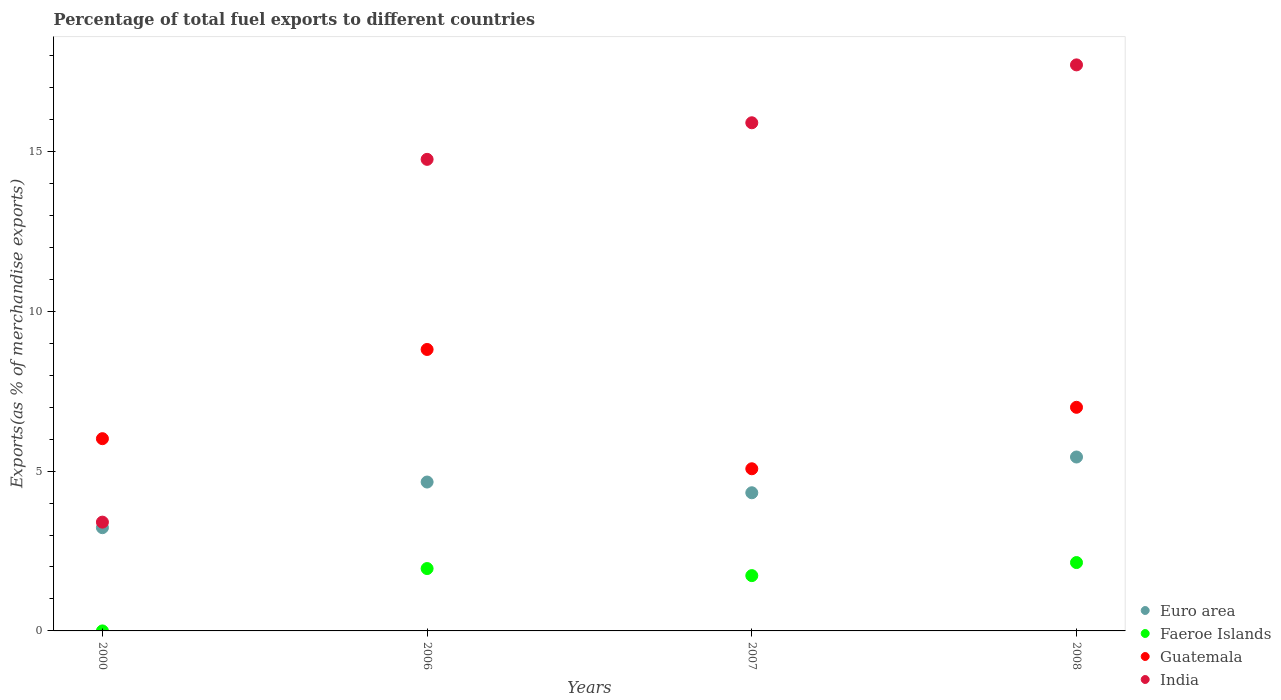What is the percentage of exports to different countries in Faeroe Islands in 2008?
Your answer should be very brief. 2.14. Across all years, what is the maximum percentage of exports to different countries in Guatemala?
Provide a short and direct response. 8.81. Across all years, what is the minimum percentage of exports to different countries in Guatemala?
Ensure brevity in your answer.  5.07. What is the total percentage of exports to different countries in Euro area in the graph?
Provide a short and direct response. 17.65. What is the difference between the percentage of exports to different countries in Guatemala in 2007 and that in 2008?
Offer a terse response. -1.92. What is the difference between the percentage of exports to different countries in Guatemala in 2006 and the percentage of exports to different countries in Euro area in 2008?
Give a very brief answer. 3.36. What is the average percentage of exports to different countries in Euro area per year?
Provide a succinct answer. 4.41. In the year 2006, what is the difference between the percentage of exports to different countries in Guatemala and percentage of exports to different countries in Euro area?
Make the answer very short. 4.15. What is the ratio of the percentage of exports to different countries in Faeroe Islands in 2006 to that in 2008?
Ensure brevity in your answer.  0.91. Is the percentage of exports to different countries in Guatemala in 2000 less than that in 2008?
Provide a succinct answer. Yes. Is the difference between the percentage of exports to different countries in Guatemala in 2000 and 2007 greater than the difference between the percentage of exports to different countries in Euro area in 2000 and 2007?
Your response must be concise. Yes. What is the difference between the highest and the second highest percentage of exports to different countries in Euro area?
Your response must be concise. 0.78. What is the difference between the highest and the lowest percentage of exports to different countries in Euro area?
Offer a terse response. 2.21. In how many years, is the percentage of exports to different countries in Faeroe Islands greater than the average percentage of exports to different countries in Faeroe Islands taken over all years?
Your response must be concise. 3. Is the sum of the percentage of exports to different countries in Faeroe Islands in 2000 and 2007 greater than the maximum percentage of exports to different countries in Euro area across all years?
Give a very brief answer. No. Is the percentage of exports to different countries in Faeroe Islands strictly less than the percentage of exports to different countries in India over the years?
Provide a short and direct response. Yes. How many dotlines are there?
Give a very brief answer. 4. Does the graph contain any zero values?
Provide a short and direct response. No. Where does the legend appear in the graph?
Offer a terse response. Bottom right. What is the title of the graph?
Give a very brief answer. Percentage of total fuel exports to different countries. What is the label or title of the X-axis?
Ensure brevity in your answer.  Years. What is the label or title of the Y-axis?
Your answer should be compact. Exports(as % of merchandise exports). What is the Exports(as % of merchandise exports) of Euro area in 2000?
Ensure brevity in your answer.  3.23. What is the Exports(as % of merchandise exports) in Faeroe Islands in 2000?
Offer a terse response. 5.55871303274651e-5. What is the Exports(as % of merchandise exports) in Guatemala in 2000?
Provide a succinct answer. 6.01. What is the Exports(as % of merchandise exports) of India in 2000?
Give a very brief answer. 3.4. What is the Exports(as % of merchandise exports) of Euro area in 2006?
Your answer should be very brief. 4.66. What is the Exports(as % of merchandise exports) in Faeroe Islands in 2006?
Your answer should be very brief. 1.95. What is the Exports(as % of merchandise exports) of Guatemala in 2006?
Ensure brevity in your answer.  8.81. What is the Exports(as % of merchandise exports) of India in 2006?
Keep it short and to the point. 14.75. What is the Exports(as % of merchandise exports) in Euro area in 2007?
Offer a very short reply. 4.32. What is the Exports(as % of merchandise exports) of Faeroe Islands in 2007?
Give a very brief answer. 1.73. What is the Exports(as % of merchandise exports) of Guatemala in 2007?
Your response must be concise. 5.07. What is the Exports(as % of merchandise exports) of India in 2007?
Provide a succinct answer. 15.9. What is the Exports(as % of merchandise exports) of Euro area in 2008?
Give a very brief answer. 5.44. What is the Exports(as % of merchandise exports) in Faeroe Islands in 2008?
Offer a very short reply. 2.14. What is the Exports(as % of merchandise exports) in Guatemala in 2008?
Keep it short and to the point. 7. What is the Exports(as % of merchandise exports) in India in 2008?
Offer a terse response. 17.71. Across all years, what is the maximum Exports(as % of merchandise exports) of Euro area?
Provide a short and direct response. 5.44. Across all years, what is the maximum Exports(as % of merchandise exports) in Faeroe Islands?
Your response must be concise. 2.14. Across all years, what is the maximum Exports(as % of merchandise exports) of Guatemala?
Your answer should be very brief. 8.81. Across all years, what is the maximum Exports(as % of merchandise exports) in India?
Make the answer very short. 17.71. Across all years, what is the minimum Exports(as % of merchandise exports) in Euro area?
Ensure brevity in your answer.  3.23. Across all years, what is the minimum Exports(as % of merchandise exports) in Faeroe Islands?
Keep it short and to the point. 5.55871303274651e-5. Across all years, what is the minimum Exports(as % of merchandise exports) in Guatemala?
Provide a succinct answer. 5.07. Across all years, what is the minimum Exports(as % of merchandise exports) in India?
Your answer should be compact. 3.4. What is the total Exports(as % of merchandise exports) in Euro area in the graph?
Keep it short and to the point. 17.65. What is the total Exports(as % of merchandise exports) of Faeroe Islands in the graph?
Your answer should be very brief. 5.82. What is the total Exports(as % of merchandise exports) in Guatemala in the graph?
Keep it short and to the point. 26.89. What is the total Exports(as % of merchandise exports) in India in the graph?
Offer a very short reply. 51.77. What is the difference between the Exports(as % of merchandise exports) in Euro area in 2000 and that in 2006?
Give a very brief answer. -1.43. What is the difference between the Exports(as % of merchandise exports) of Faeroe Islands in 2000 and that in 2006?
Ensure brevity in your answer.  -1.95. What is the difference between the Exports(as % of merchandise exports) in Guatemala in 2000 and that in 2006?
Your response must be concise. -2.79. What is the difference between the Exports(as % of merchandise exports) in India in 2000 and that in 2006?
Provide a short and direct response. -11.35. What is the difference between the Exports(as % of merchandise exports) in Euro area in 2000 and that in 2007?
Your answer should be compact. -1.09. What is the difference between the Exports(as % of merchandise exports) of Faeroe Islands in 2000 and that in 2007?
Your answer should be very brief. -1.73. What is the difference between the Exports(as % of merchandise exports) in Guatemala in 2000 and that in 2007?
Your response must be concise. 0.94. What is the difference between the Exports(as % of merchandise exports) of India in 2000 and that in 2007?
Provide a short and direct response. -12.5. What is the difference between the Exports(as % of merchandise exports) in Euro area in 2000 and that in 2008?
Provide a short and direct response. -2.21. What is the difference between the Exports(as % of merchandise exports) in Faeroe Islands in 2000 and that in 2008?
Provide a short and direct response. -2.14. What is the difference between the Exports(as % of merchandise exports) of Guatemala in 2000 and that in 2008?
Your answer should be very brief. -0.98. What is the difference between the Exports(as % of merchandise exports) of India in 2000 and that in 2008?
Make the answer very short. -14.31. What is the difference between the Exports(as % of merchandise exports) in Euro area in 2006 and that in 2007?
Keep it short and to the point. 0.34. What is the difference between the Exports(as % of merchandise exports) in Faeroe Islands in 2006 and that in 2007?
Give a very brief answer. 0.22. What is the difference between the Exports(as % of merchandise exports) in Guatemala in 2006 and that in 2007?
Offer a terse response. 3.73. What is the difference between the Exports(as % of merchandise exports) of India in 2006 and that in 2007?
Provide a succinct answer. -1.14. What is the difference between the Exports(as % of merchandise exports) of Euro area in 2006 and that in 2008?
Offer a terse response. -0.78. What is the difference between the Exports(as % of merchandise exports) in Faeroe Islands in 2006 and that in 2008?
Your answer should be compact. -0.19. What is the difference between the Exports(as % of merchandise exports) in Guatemala in 2006 and that in 2008?
Offer a terse response. 1.81. What is the difference between the Exports(as % of merchandise exports) in India in 2006 and that in 2008?
Offer a very short reply. -2.96. What is the difference between the Exports(as % of merchandise exports) in Euro area in 2007 and that in 2008?
Keep it short and to the point. -1.12. What is the difference between the Exports(as % of merchandise exports) in Faeroe Islands in 2007 and that in 2008?
Your answer should be very brief. -0.41. What is the difference between the Exports(as % of merchandise exports) in Guatemala in 2007 and that in 2008?
Provide a short and direct response. -1.92. What is the difference between the Exports(as % of merchandise exports) in India in 2007 and that in 2008?
Ensure brevity in your answer.  -1.81. What is the difference between the Exports(as % of merchandise exports) in Euro area in 2000 and the Exports(as % of merchandise exports) in Faeroe Islands in 2006?
Your answer should be very brief. 1.28. What is the difference between the Exports(as % of merchandise exports) of Euro area in 2000 and the Exports(as % of merchandise exports) of Guatemala in 2006?
Keep it short and to the point. -5.58. What is the difference between the Exports(as % of merchandise exports) in Euro area in 2000 and the Exports(as % of merchandise exports) in India in 2006?
Give a very brief answer. -11.52. What is the difference between the Exports(as % of merchandise exports) of Faeroe Islands in 2000 and the Exports(as % of merchandise exports) of Guatemala in 2006?
Your response must be concise. -8.81. What is the difference between the Exports(as % of merchandise exports) in Faeroe Islands in 2000 and the Exports(as % of merchandise exports) in India in 2006?
Your response must be concise. -14.75. What is the difference between the Exports(as % of merchandise exports) in Guatemala in 2000 and the Exports(as % of merchandise exports) in India in 2006?
Make the answer very short. -8.74. What is the difference between the Exports(as % of merchandise exports) of Euro area in 2000 and the Exports(as % of merchandise exports) of Faeroe Islands in 2007?
Provide a short and direct response. 1.5. What is the difference between the Exports(as % of merchandise exports) of Euro area in 2000 and the Exports(as % of merchandise exports) of Guatemala in 2007?
Offer a very short reply. -1.84. What is the difference between the Exports(as % of merchandise exports) in Euro area in 2000 and the Exports(as % of merchandise exports) in India in 2007?
Your answer should be compact. -12.67. What is the difference between the Exports(as % of merchandise exports) of Faeroe Islands in 2000 and the Exports(as % of merchandise exports) of Guatemala in 2007?
Offer a very short reply. -5.07. What is the difference between the Exports(as % of merchandise exports) of Faeroe Islands in 2000 and the Exports(as % of merchandise exports) of India in 2007?
Your response must be concise. -15.9. What is the difference between the Exports(as % of merchandise exports) in Guatemala in 2000 and the Exports(as % of merchandise exports) in India in 2007?
Make the answer very short. -9.88. What is the difference between the Exports(as % of merchandise exports) in Euro area in 2000 and the Exports(as % of merchandise exports) in Faeroe Islands in 2008?
Your answer should be compact. 1.09. What is the difference between the Exports(as % of merchandise exports) in Euro area in 2000 and the Exports(as % of merchandise exports) in Guatemala in 2008?
Your answer should be compact. -3.77. What is the difference between the Exports(as % of merchandise exports) in Euro area in 2000 and the Exports(as % of merchandise exports) in India in 2008?
Keep it short and to the point. -14.48. What is the difference between the Exports(as % of merchandise exports) of Faeroe Islands in 2000 and the Exports(as % of merchandise exports) of Guatemala in 2008?
Offer a very short reply. -7. What is the difference between the Exports(as % of merchandise exports) of Faeroe Islands in 2000 and the Exports(as % of merchandise exports) of India in 2008?
Your answer should be very brief. -17.71. What is the difference between the Exports(as % of merchandise exports) of Guatemala in 2000 and the Exports(as % of merchandise exports) of India in 2008?
Give a very brief answer. -11.7. What is the difference between the Exports(as % of merchandise exports) in Euro area in 2006 and the Exports(as % of merchandise exports) in Faeroe Islands in 2007?
Offer a terse response. 2.93. What is the difference between the Exports(as % of merchandise exports) in Euro area in 2006 and the Exports(as % of merchandise exports) in Guatemala in 2007?
Keep it short and to the point. -0.41. What is the difference between the Exports(as % of merchandise exports) of Euro area in 2006 and the Exports(as % of merchandise exports) of India in 2007?
Your answer should be very brief. -11.24. What is the difference between the Exports(as % of merchandise exports) in Faeroe Islands in 2006 and the Exports(as % of merchandise exports) in Guatemala in 2007?
Your answer should be very brief. -3.12. What is the difference between the Exports(as % of merchandise exports) of Faeroe Islands in 2006 and the Exports(as % of merchandise exports) of India in 2007?
Give a very brief answer. -13.95. What is the difference between the Exports(as % of merchandise exports) of Guatemala in 2006 and the Exports(as % of merchandise exports) of India in 2007?
Offer a terse response. -7.09. What is the difference between the Exports(as % of merchandise exports) in Euro area in 2006 and the Exports(as % of merchandise exports) in Faeroe Islands in 2008?
Ensure brevity in your answer.  2.52. What is the difference between the Exports(as % of merchandise exports) of Euro area in 2006 and the Exports(as % of merchandise exports) of Guatemala in 2008?
Provide a succinct answer. -2.34. What is the difference between the Exports(as % of merchandise exports) in Euro area in 2006 and the Exports(as % of merchandise exports) in India in 2008?
Provide a succinct answer. -13.05. What is the difference between the Exports(as % of merchandise exports) of Faeroe Islands in 2006 and the Exports(as % of merchandise exports) of Guatemala in 2008?
Provide a short and direct response. -5.04. What is the difference between the Exports(as % of merchandise exports) in Faeroe Islands in 2006 and the Exports(as % of merchandise exports) in India in 2008?
Offer a terse response. -15.76. What is the difference between the Exports(as % of merchandise exports) of Guatemala in 2006 and the Exports(as % of merchandise exports) of India in 2008?
Provide a succinct answer. -8.9. What is the difference between the Exports(as % of merchandise exports) of Euro area in 2007 and the Exports(as % of merchandise exports) of Faeroe Islands in 2008?
Ensure brevity in your answer.  2.18. What is the difference between the Exports(as % of merchandise exports) in Euro area in 2007 and the Exports(as % of merchandise exports) in Guatemala in 2008?
Your response must be concise. -2.67. What is the difference between the Exports(as % of merchandise exports) of Euro area in 2007 and the Exports(as % of merchandise exports) of India in 2008?
Provide a succinct answer. -13.39. What is the difference between the Exports(as % of merchandise exports) of Faeroe Islands in 2007 and the Exports(as % of merchandise exports) of Guatemala in 2008?
Give a very brief answer. -5.27. What is the difference between the Exports(as % of merchandise exports) of Faeroe Islands in 2007 and the Exports(as % of merchandise exports) of India in 2008?
Ensure brevity in your answer.  -15.98. What is the difference between the Exports(as % of merchandise exports) of Guatemala in 2007 and the Exports(as % of merchandise exports) of India in 2008?
Provide a succinct answer. -12.64. What is the average Exports(as % of merchandise exports) of Euro area per year?
Your answer should be compact. 4.41. What is the average Exports(as % of merchandise exports) in Faeroe Islands per year?
Offer a very short reply. 1.46. What is the average Exports(as % of merchandise exports) in Guatemala per year?
Your answer should be very brief. 6.72. What is the average Exports(as % of merchandise exports) in India per year?
Make the answer very short. 12.94. In the year 2000, what is the difference between the Exports(as % of merchandise exports) of Euro area and Exports(as % of merchandise exports) of Faeroe Islands?
Keep it short and to the point. 3.23. In the year 2000, what is the difference between the Exports(as % of merchandise exports) of Euro area and Exports(as % of merchandise exports) of Guatemala?
Give a very brief answer. -2.78. In the year 2000, what is the difference between the Exports(as % of merchandise exports) in Euro area and Exports(as % of merchandise exports) in India?
Provide a short and direct response. -0.17. In the year 2000, what is the difference between the Exports(as % of merchandise exports) in Faeroe Islands and Exports(as % of merchandise exports) in Guatemala?
Provide a succinct answer. -6.01. In the year 2000, what is the difference between the Exports(as % of merchandise exports) of Faeroe Islands and Exports(as % of merchandise exports) of India?
Your answer should be very brief. -3.4. In the year 2000, what is the difference between the Exports(as % of merchandise exports) in Guatemala and Exports(as % of merchandise exports) in India?
Your answer should be compact. 2.61. In the year 2006, what is the difference between the Exports(as % of merchandise exports) of Euro area and Exports(as % of merchandise exports) of Faeroe Islands?
Ensure brevity in your answer.  2.71. In the year 2006, what is the difference between the Exports(as % of merchandise exports) of Euro area and Exports(as % of merchandise exports) of Guatemala?
Offer a terse response. -4.15. In the year 2006, what is the difference between the Exports(as % of merchandise exports) of Euro area and Exports(as % of merchandise exports) of India?
Provide a succinct answer. -10.1. In the year 2006, what is the difference between the Exports(as % of merchandise exports) in Faeroe Islands and Exports(as % of merchandise exports) in Guatemala?
Your answer should be compact. -6.85. In the year 2006, what is the difference between the Exports(as % of merchandise exports) in Faeroe Islands and Exports(as % of merchandise exports) in India?
Provide a succinct answer. -12.8. In the year 2006, what is the difference between the Exports(as % of merchandise exports) of Guatemala and Exports(as % of merchandise exports) of India?
Provide a succinct answer. -5.95. In the year 2007, what is the difference between the Exports(as % of merchandise exports) in Euro area and Exports(as % of merchandise exports) in Faeroe Islands?
Provide a succinct answer. 2.59. In the year 2007, what is the difference between the Exports(as % of merchandise exports) in Euro area and Exports(as % of merchandise exports) in Guatemala?
Provide a short and direct response. -0.75. In the year 2007, what is the difference between the Exports(as % of merchandise exports) of Euro area and Exports(as % of merchandise exports) of India?
Offer a very short reply. -11.58. In the year 2007, what is the difference between the Exports(as % of merchandise exports) in Faeroe Islands and Exports(as % of merchandise exports) in Guatemala?
Your answer should be very brief. -3.34. In the year 2007, what is the difference between the Exports(as % of merchandise exports) in Faeroe Islands and Exports(as % of merchandise exports) in India?
Offer a very short reply. -14.17. In the year 2007, what is the difference between the Exports(as % of merchandise exports) in Guatemala and Exports(as % of merchandise exports) in India?
Ensure brevity in your answer.  -10.83. In the year 2008, what is the difference between the Exports(as % of merchandise exports) of Euro area and Exports(as % of merchandise exports) of Faeroe Islands?
Make the answer very short. 3.3. In the year 2008, what is the difference between the Exports(as % of merchandise exports) of Euro area and Exports(as % of merchandise exports) of Guatemala?
Make the answer very short. -1.55. In the year 2008, what is the difference between the Exports(as % of merchandise exports) in Euro area and Exports(as % of merchandise exports) in India?
Give a very brief answer. -12.27. In the year 2008, what is the difference between the Exports(as % of merchandise exports) in Faeroe Islands and Exports(as % of merchandise exports) in Guatemala?
Offer a very short reply. -4.86. In the year 2008, what is the difference between the Exports(as % of merchandise exports) of Faeroe Islands and Exports(as % of merchandise exports) of India?
Your answer should be very brief. -15.57. In the year 2008, what is the difference between the Exports(as % of merchandise exports) of Guatemala and Exports(as % of merchandise exports) of India?
Give a very brief answer. -10.71. What is the ratio of the Exports(as % of merchandise exports) in Euro area in 2000 to that in 2006?
Your answer should be very brief. 0.69. What is the ratio of the Exports(as % of merchandise exports) of Faeroe Islands in 2000 to that in 2006?
Provide a short and direct response. 0. What is the ratio of the Exports(as % of merchandise exports) of Guatemala in 2000 to that in 2006?
Provide a short and direct response. 0.68. What is the ratio of the Exports(as % of merchandise exports) in India in 2000 to that in 2006?
Ensure brevity in your answer.  0.23. What is the ratio of the Exports(as % of merchandise exports) of Euro area in 2000 to that in 2007?
Make the answer very short. 0.75. What is the ratio of the Exports(as % of merchandise exports) in Guatemala in 2000 to that in 2007?
Offer a terse response. 1.19. What is the ratio of the Exports(as % of merchandise exports) of India in 2000 to that in 2007?
Give a very brief answer. 0.21. What is the ratio of the Exports(as % of merchandise exports) in Euro area in 2000 to that in 2008?
Give a very brief answer. 0.59. What is the ratio of the Exports(as % of merchandise exports) in Faeroe Islands in 2000 to that in 2008?
Keep it short and to the point. 0. What is the ratio of the Exports(as % of merchandise exports) of Guatemala in 2000 to that in 2008?
Provide a succinct answer. 0.86. What is the ratio of the Exports(as % of merchandise exports) in India in 2000 to that in 2008?
Offer a terse response. 0.19. What is the ratio of the Exports(as % of merchandise exports) in Euro area in 2006 to that in 2007?
Provide a succinct answer. 1.08. What is the ratio of the Exports(as % of merchandise exports) in Faeroe Islands in 2006 to that in 2007?
Your response must be concise. 1.13. What is the ratio of the Exports(as % of merchandise exports) in Guatemala in 2006 to that in 2007?
Your answer should be very brief. 1.74. What is the ratio of the Exports(as % of merchandise exports) of India in 2006 to that in 2007?
Offer a very short reply. 0.93. What is the ratio of the Exports(as % of merchandise exports) in Euro area in 2006 to that in 2008?
Offer a terse response. 0.86. What is the ratio of the Exports(as % of merchandise exports) of Faeroe Islands in 2006 to that in 2008?
Make the answer very short. 0.91. What is the ratio of the Exports(as % of merchandise exports) of Guatemala in 2006 to that in 2008?
Give a very brief answer. 1.26. What is the ratio of the Exports(as % of merchandise exports) in India in 2006 to that in 2008?
Your answer should be compact. 0.83. What is the ratio of the Exports(as % of merchandise exports) of Euro area in 2007 to that in 2008?
Your response must be concise. 0.79. What is the ratio of the Exports(as % of merchandise exports) in Faeroe Islands in 2007 to that in 2008?
Ensure brevity in your answer.  0.81. What is the ratio of the Exports(as % of merchandise exports) of Guatemala in 2007 to that in 2008?
Your response must be concise. 0.73. What is the ratio of the Exports(as % of merchandise exports) in India in 2007 to that in 2008?
Your response must be concise. 0.9. What is the difference between the highest and the second highest Exports(as % of merchandise exports) in Euro area?
Ensure brevity in your answer.  0.78. What is the difference between the highest and the second highest Exports(as % of merchandise exports) in Faeroe Islands?
Your response must be concise. 0.19. What is the difference between the highest and the second highest Exports(as % of merchandise exports) of Guatemala?
Make the answer very short. 1.81. What is the difference between the highest and the second highest Exports(as % of merchandise exports) of India?
Provide a short and direct response. 1.81. What is the difference between the highest and the lowest Exports(as % of merchandise exports) in Euro area?
Provide a succinct answer. 2.21. What is the difference between the highest and the lowest Exports(as % of merchandise exports) of Faeroe Islands?
Give a very brief answer. 2.14. What is the difference between the highest and the lowest Exports(as % of merchandise exports) in Guatemala?
Your answer should be compact. 3.73. What is the difference between the highest and the lowest Exports(as % of merchandise exports) of India?
Provide a short and direct response. 14.31. 